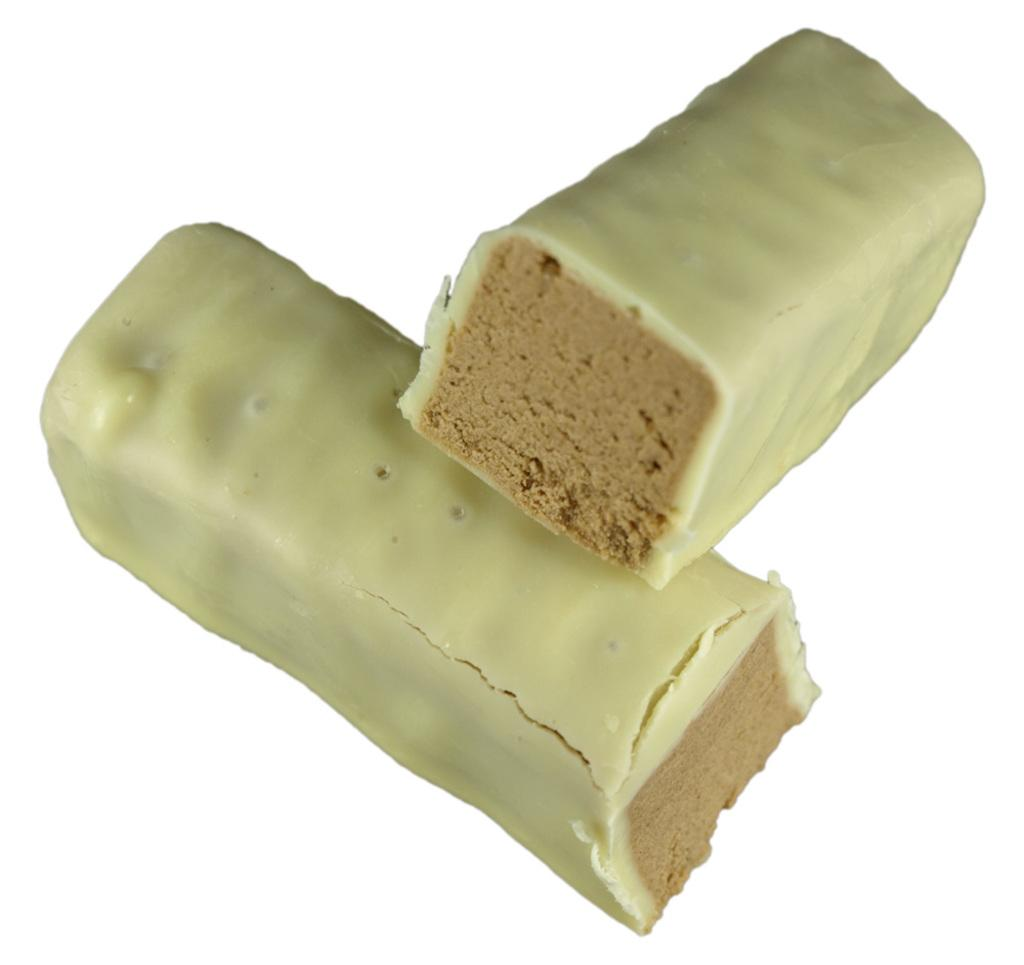What is the main subject of the image? The main subject of the image is food items. Can you describe the food items in the image? The food items appear to be chocolates. What color is the background of the image? The background of the image is white in color. What is the condition of the story being told in the image? There is no story being told in the image; it only features chocolates in the center and a white background. 